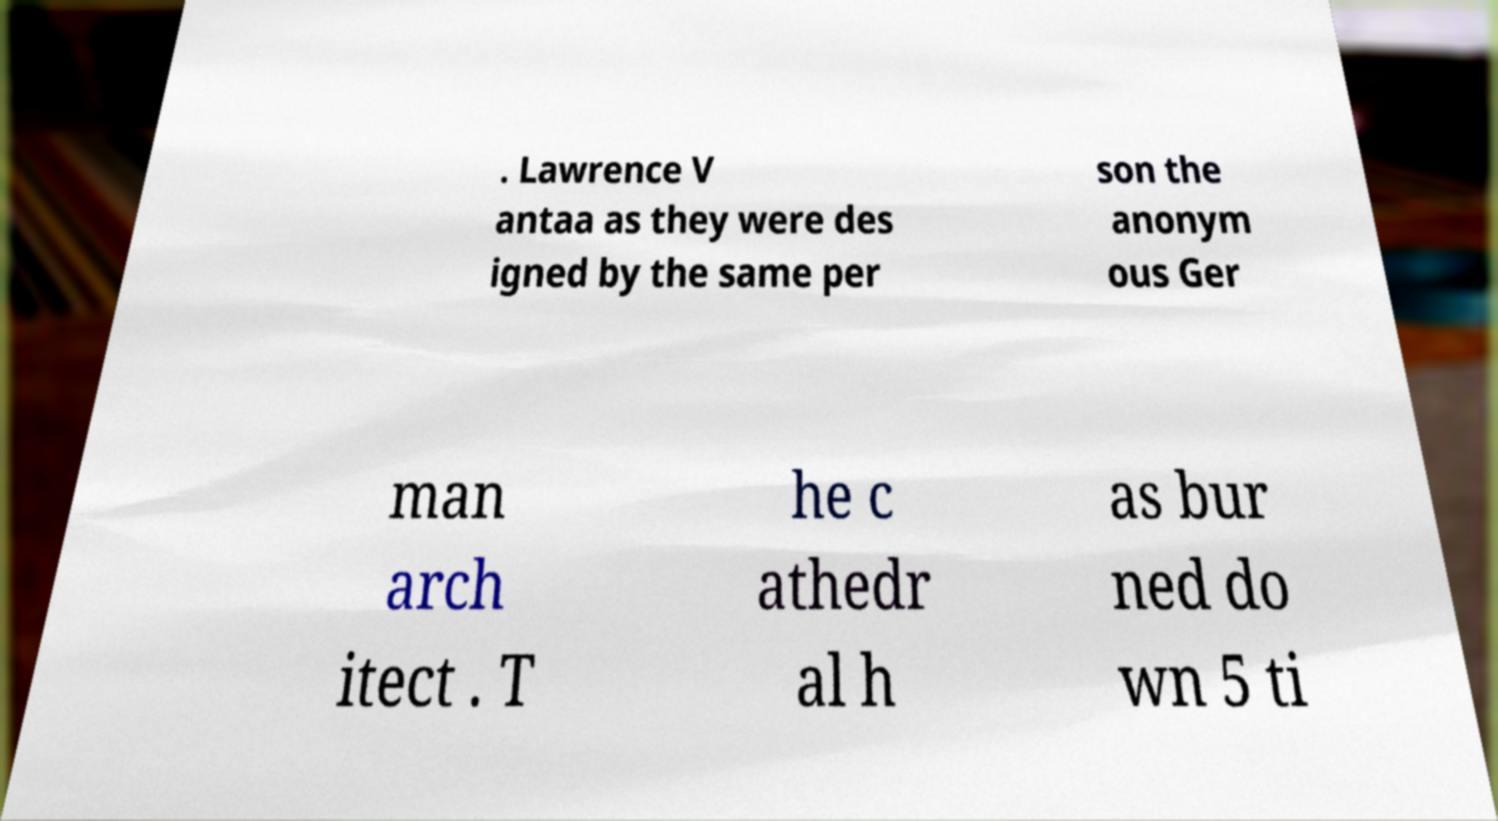Could you extract and type out the text from this image? . Lawrence V antaa as they were des igned by the same per son the anonym ous Ger man arch itect . T he c athedr al h as bur ned do wn 5 ti 